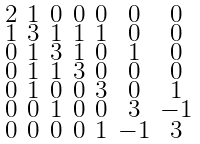<formula> <loc_0><loc_0><loc_500><loc_500>\begin{smallmatrix} 2 & 1 & 0 & 0 & 0 & 0 & 0 \\ 1 & 3 & 1 & 1 & 1 & 0 & 0 \\ 0 & 1 & 3 & 1 & 0 & 1 & 0 \\ 0 & 1 & 1 & 3 & 0 & 0 & 0 \\ 0 & 1 & 0 & 0 & 3 & 0 & 1 \\ 0 & 0 & 1 & 0 & 0 & 3 & - 1 \\ 0 & 0 & 0 & 0 & 1 & - 1 & 3 \end{smallmatrix}</formula> 